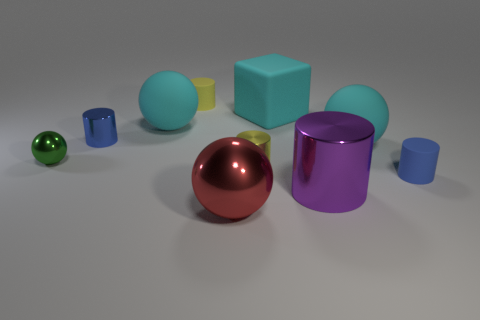What size is the metal thing that is both in front of the blue matte cylinder and behind the red thing?
Your response must be concise. Large. What is the small blue thing in front of the tiny ball made of?
Make the answer very short. Rubber. Do the block and the big sphere to the left of the red shiny thing have the same color?
Give a very brief answer. Yes. What number of objects are cyan balls that are on the left side of the tiny yellow metallic thing or big spheres that are in front of the blue metal object?
Give a very brief answer. 3. There is a metallic cylinder that is in front of the small green shiny ball and behind the purple shiny thing; what is its color?
Offer a very short reply. Yellow. Are there more cyan matte cubes than large cyan matte spheres?
Provide a short and direct response. No. Does the cyan object left of the yellow shiny object have the same shape as the small green thing?
Keep it short and to the point. Yes. What number of shiny things are cyan spheres or tiny cyan spheres?
Your answer should be very brief. 0. Are there any large cubes made of the same material as the purple cylinder?
Ensure brevity in your answer.  No. What is the material of the large block?
Offer a terse response. Rubber. 